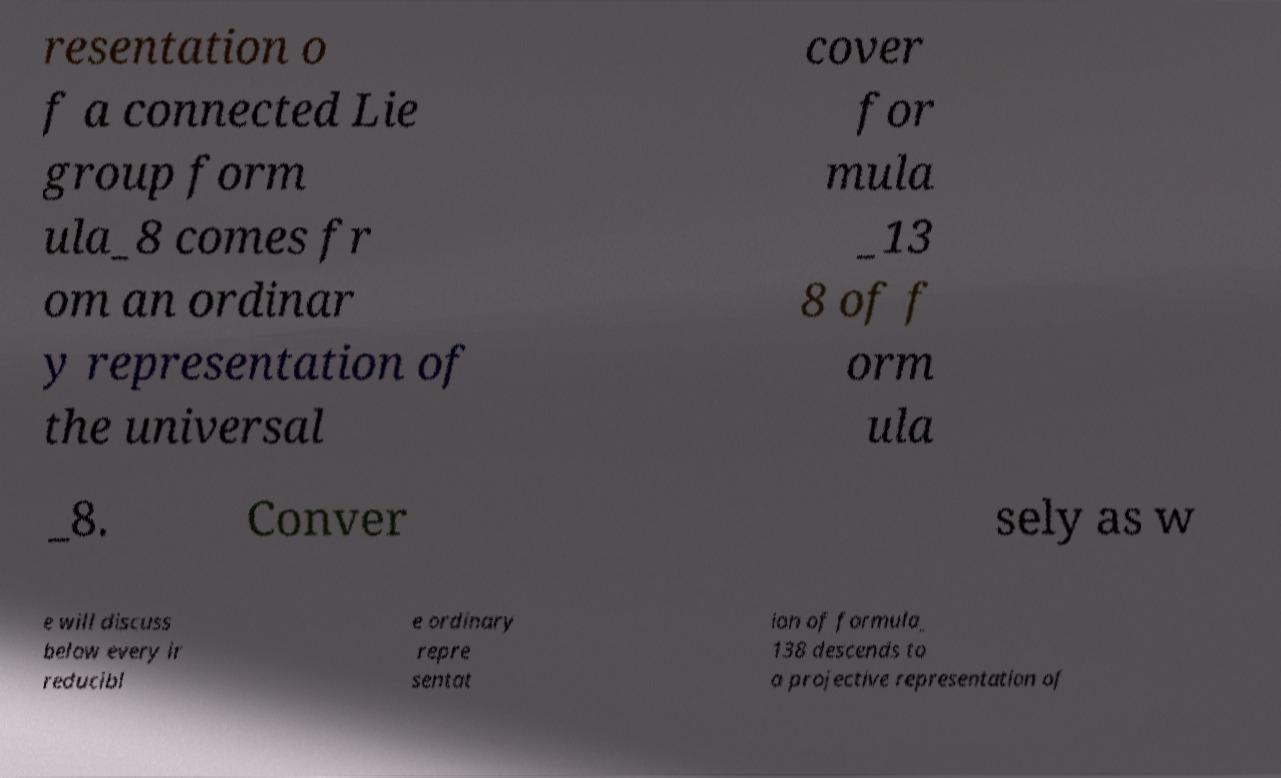Could you extract and type out the text from this image? resentation o f a connected Lie group form ula_8 comes fr om an ordinar y representation of the universal cover for mula _13 8 of f orm ula _8. Conver sely as w e will discuss below every ir reducibl e ordinary repre sentat ion of formula_ 138 descends to a projective representation of 